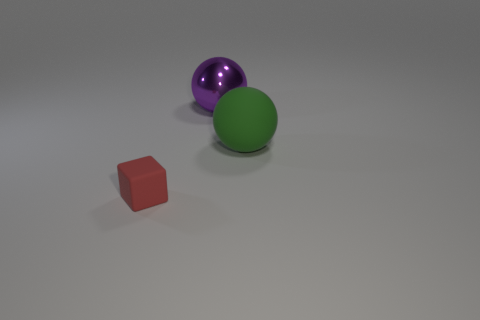Add 2 blue shiny balls. How many objects exist? 5 Subtract all spheres. How many objects are left? 1 Add 1 red cubes. How many red cubes exist? 2 Subtract 0 brown cubes. How many objects are left? 3 Subtract all small blue cylinders. Subtract all purple spheres. How many objects are left? 2 Add 3 shiny things. How many shiny things are left? 4 